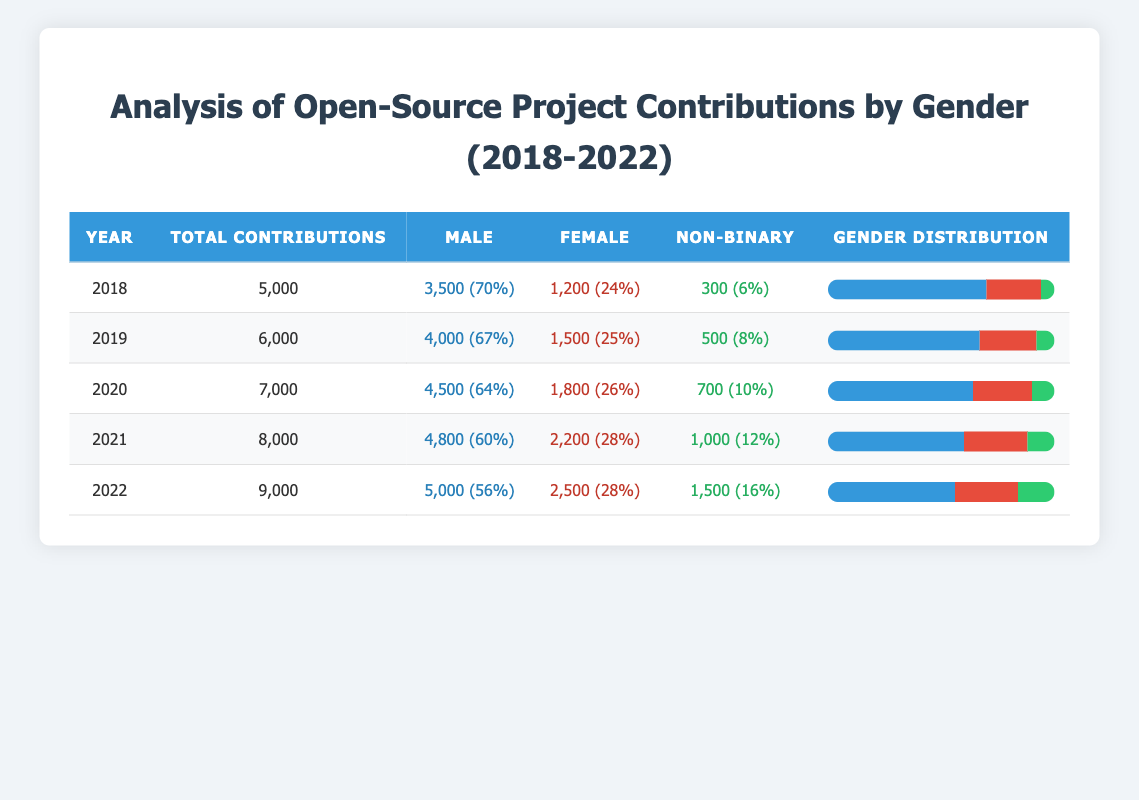What was the total number of contributions in 2020? In the table, for the year 2020, the total contributions listed in the second column are 7,000.
Answer: 7,000 What percentage of contributions in 2019 came from non-binary contributors? From the table for 2019, non-binary contributions are 500, which is 8% of the total contributions of 6,000.
Answer: 8% Which year saw the highest number of female contributions? Looking at the female contributions column, the year 2022 shows the highest value of 2,500.
Answer: 2022 What was the average percentage of male contributions over the five years? The male percentages for each year are 70, 67, 64, 60, and 56. Adding them gives 317, and dividing by 5 results in 63.4.
Answer: 63.4 Did the percentage of male contributions decrease every year from 2018 to 2022? We observe the male percentages: 70% (2018), 67% (2019), 64% (2020), 60% (2021), 56% (2022). Each year has a lower percentage.
Answer: Yes How many more female contributions were there in 2021 compared to 2018? In 2021, female contributions were 2,200, and in 2018, they were 1,200. The difference is 2,200 - 1,200 = 1,000.
Answer: 1,000 What is the total contribution count for males from 2018 to 2022? Summing the male contributions: 3,500 (2018) + 4,000 (2019) + 4,500 (2020) + 4,800 (2021) + 5,000 (2022) equals 21,800.
Answer: 21,800 What was the non-binary contribution percentage in 2021? In 2021, the table indicates that non-binary contributions were 1,000 out of 8,000 total contributions, which is 12%.
Answer: 12% In which year did female contributions first exceed 2,000? Female contributions exceeded 2,000 for the first time in 2021, where there were 2,200 contributions.
Answer: 2021 